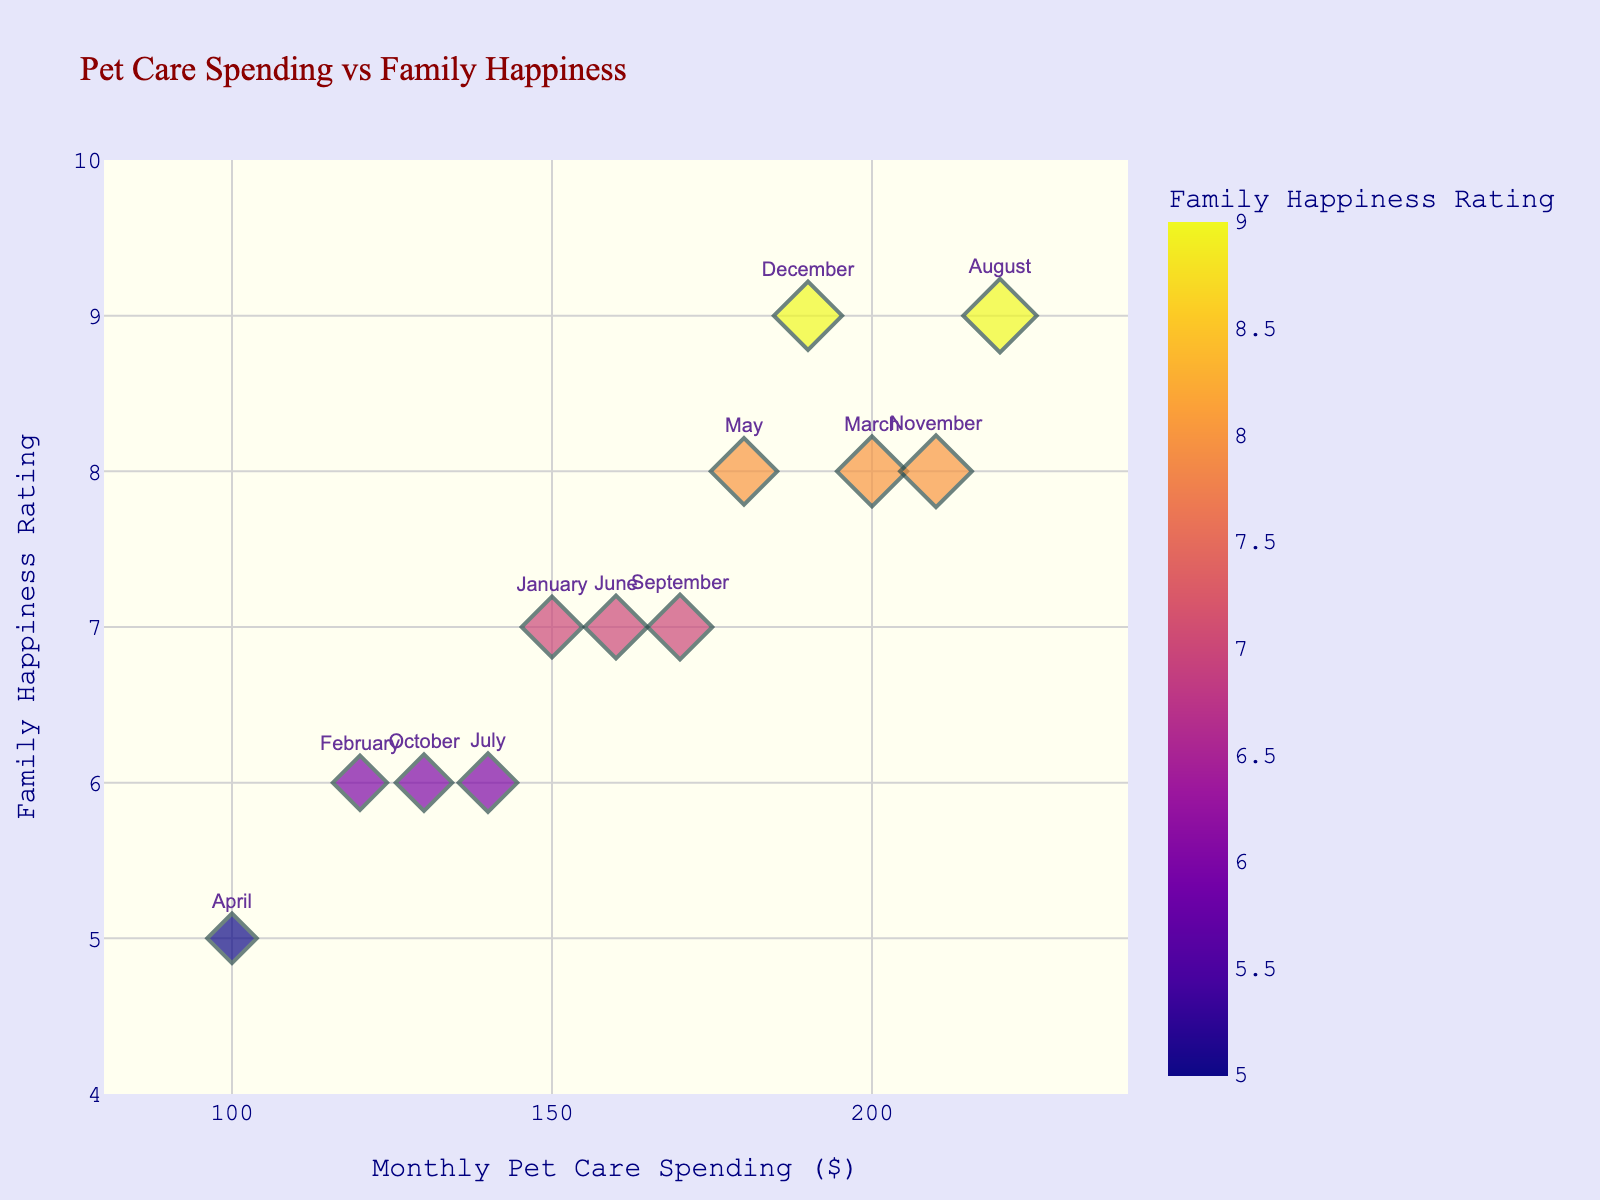What is the title of the plot? The title is shown at the top of the plot.
Answer: Pet Care Spending vs Family Happiness What are the x-axis and y-axis labels? The labels are shown on the x-axis and y-axis of the plot.
Answer: x-axis: Monthly Pet Care Spending ($), y-axis: Family Happiness Rating Which month had the highest spending on pet care? Find the dot with the highest x-axis value.
Answer: August Which month had the lowest happiness rating? Find the dot with the lowest y-axis value.
Answer: April What is the average Family Happiness Rating across all months? Sum all Family Happiness Ratings and divide by the number of months: (7 + 6 + 8 + 5 + 8 + 7 + 6 + 9 + 7 + 6 + 8 + 9) / 12.
Answer: 7 Is there a positive correlation between pet care spending and family happiness? Observe the general trend of the data points.
Answer: Yes, generally higher spending is associated with higher happiness ratings Which months have a Family Happiness Rating of 8? Identify months on or near the line y=8.
Answer: March, May, November How much did the family spend on pet care in December? Locate the "December" point and read the x-axis value.
Answer: $190 Which month had the largest difference between pet care spending and happiness rating? Calculate the absolute difference between spending and rating for each month, identify the largest difference.
Answer: August (220 - 9 = 211) What is the range of pet care spending across the year? Subtract the smallest spending value from the largest spending value.
Answer: 220 - 100 = 120 